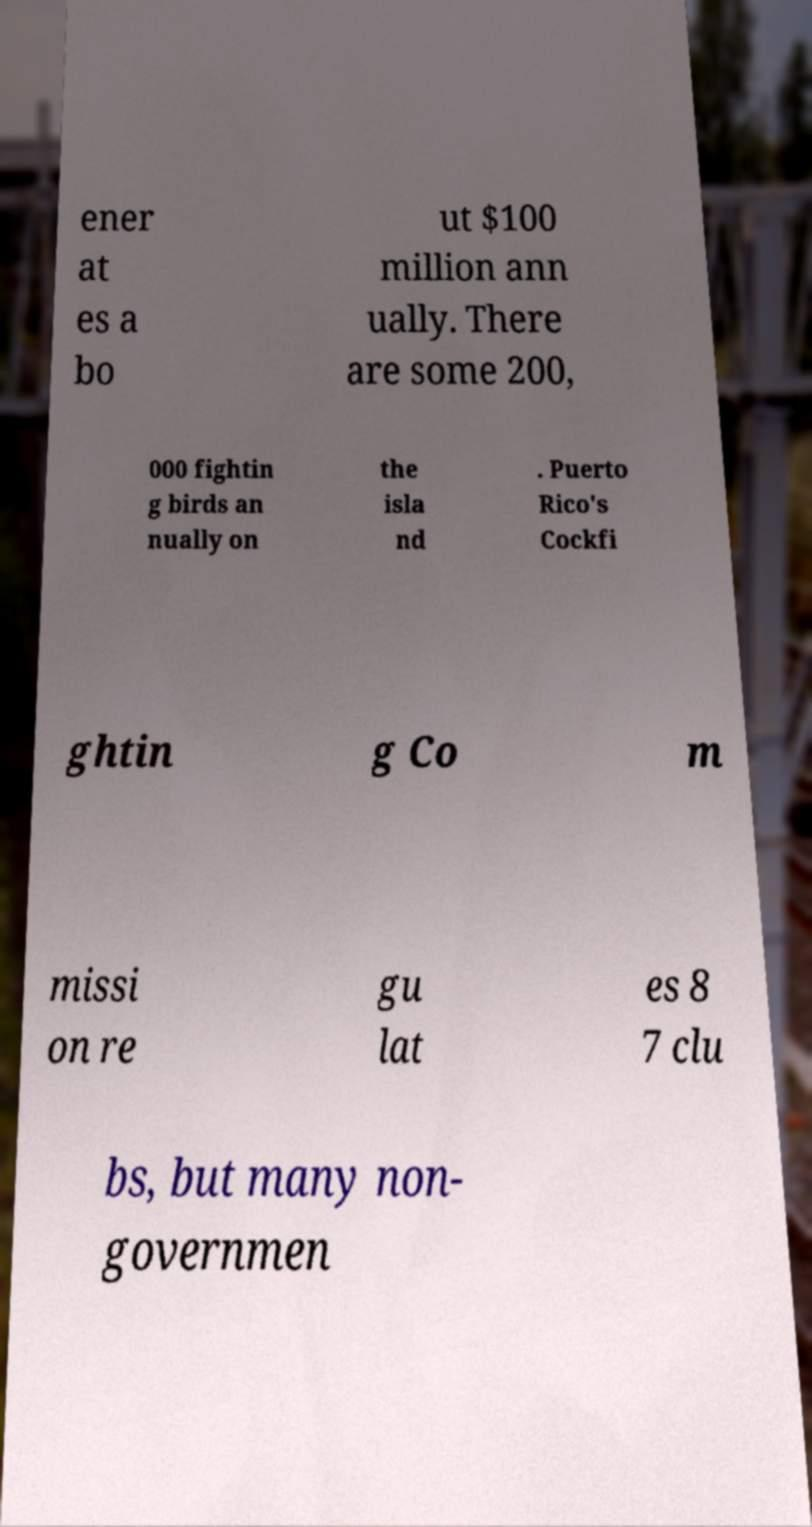Please identify and transcribe the text found in this image. ener at es a bo ut $100 million ann ually. There are some 200, 000 fightin g birds an nually on the isla nd . Puerto Rico's Cockfi ghtin g Co m missi on re gu lat es 8 7 clu bs, but many non- governmen 